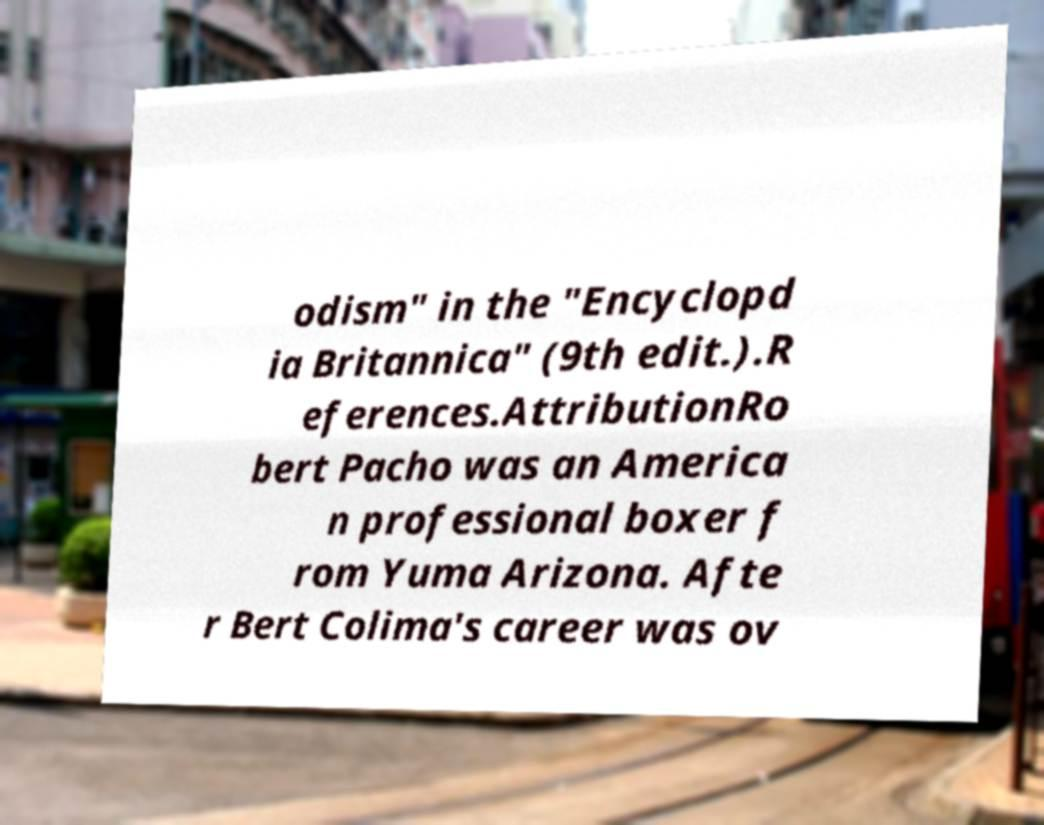Please identify and transcribe the text found in this image. odism" in the "Encyclopd ia Britannica" (9th edit.).R eferences.AttributionRo bert Pacho was an America n professional boxer f rom Yuma Arizona. Afte r Bert Colima's career was ov 